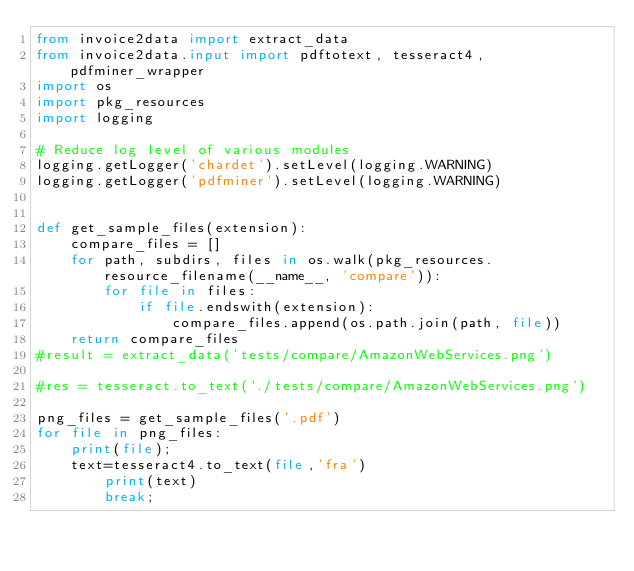Convert code to text. <code><loc_0><loc_0><loc_500><loc_500><_Python_>from invoice2data import extract_data
from invoice2data.input import pdftotext, tesseract4, pdfminer_wrapper
import os
import pkg_resources
import logging

# Reduce log level of various modules
logging.getLogger('chardet').setLevel(logging.WARNING)
logging.getLogger('pdfminer').setLevel(logging.WARNING)


def get_sample_files(extension):
    compare_files = []
    for path, subdirs, files in os.walk(pkg_resources.resource_filename(__name__, 'compare')):
        for file in files:
            if file.endswith(extension):
                compare_files.append(os.path.join(path, file))
    return compare_files
#result = extract_data('tests/compare/AmazonWebServices.png')

#res = tesseract.to_text('./tests/compare/AmazonWebServices.png')

png_files = get_sample_files('.pdf')
for file in png_files:
	print(file);
	text=tesseract4.to_text(file,'fra')
    	print(text)
    	break;
</code> 